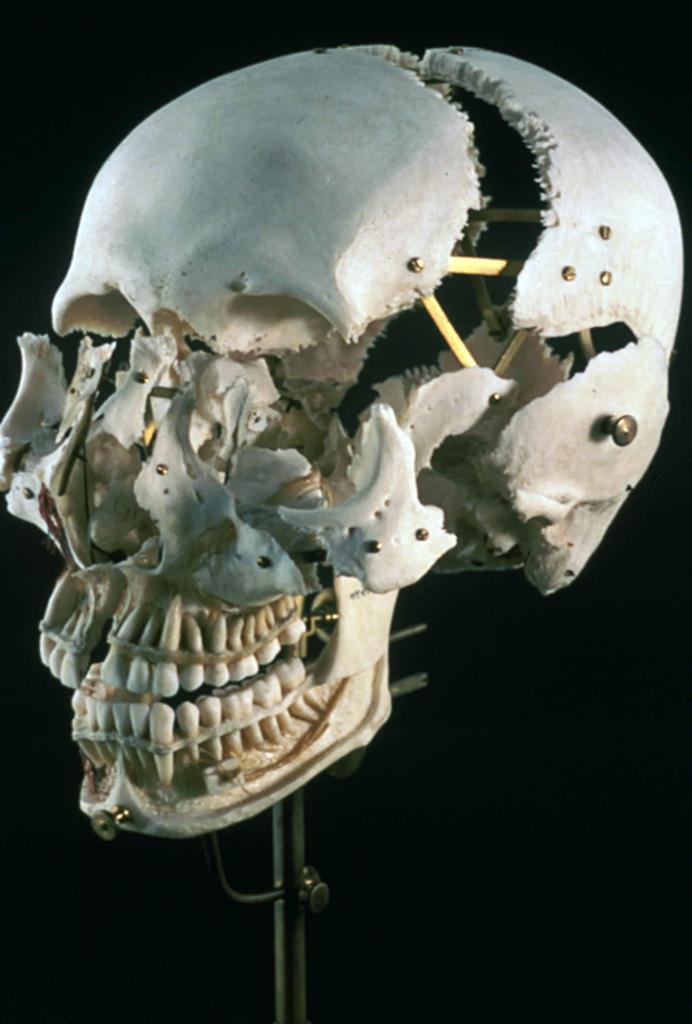What is the main subject of the image? The main subject of the image is a broken skull. Where is the broken skull located in the image? The broken skull is on a stand. What type of organization is responsible for the minute robin in the image? There is no organization, minute robin, or any other unrelated elements present in the image. The image only features a broken skull on a stand. 